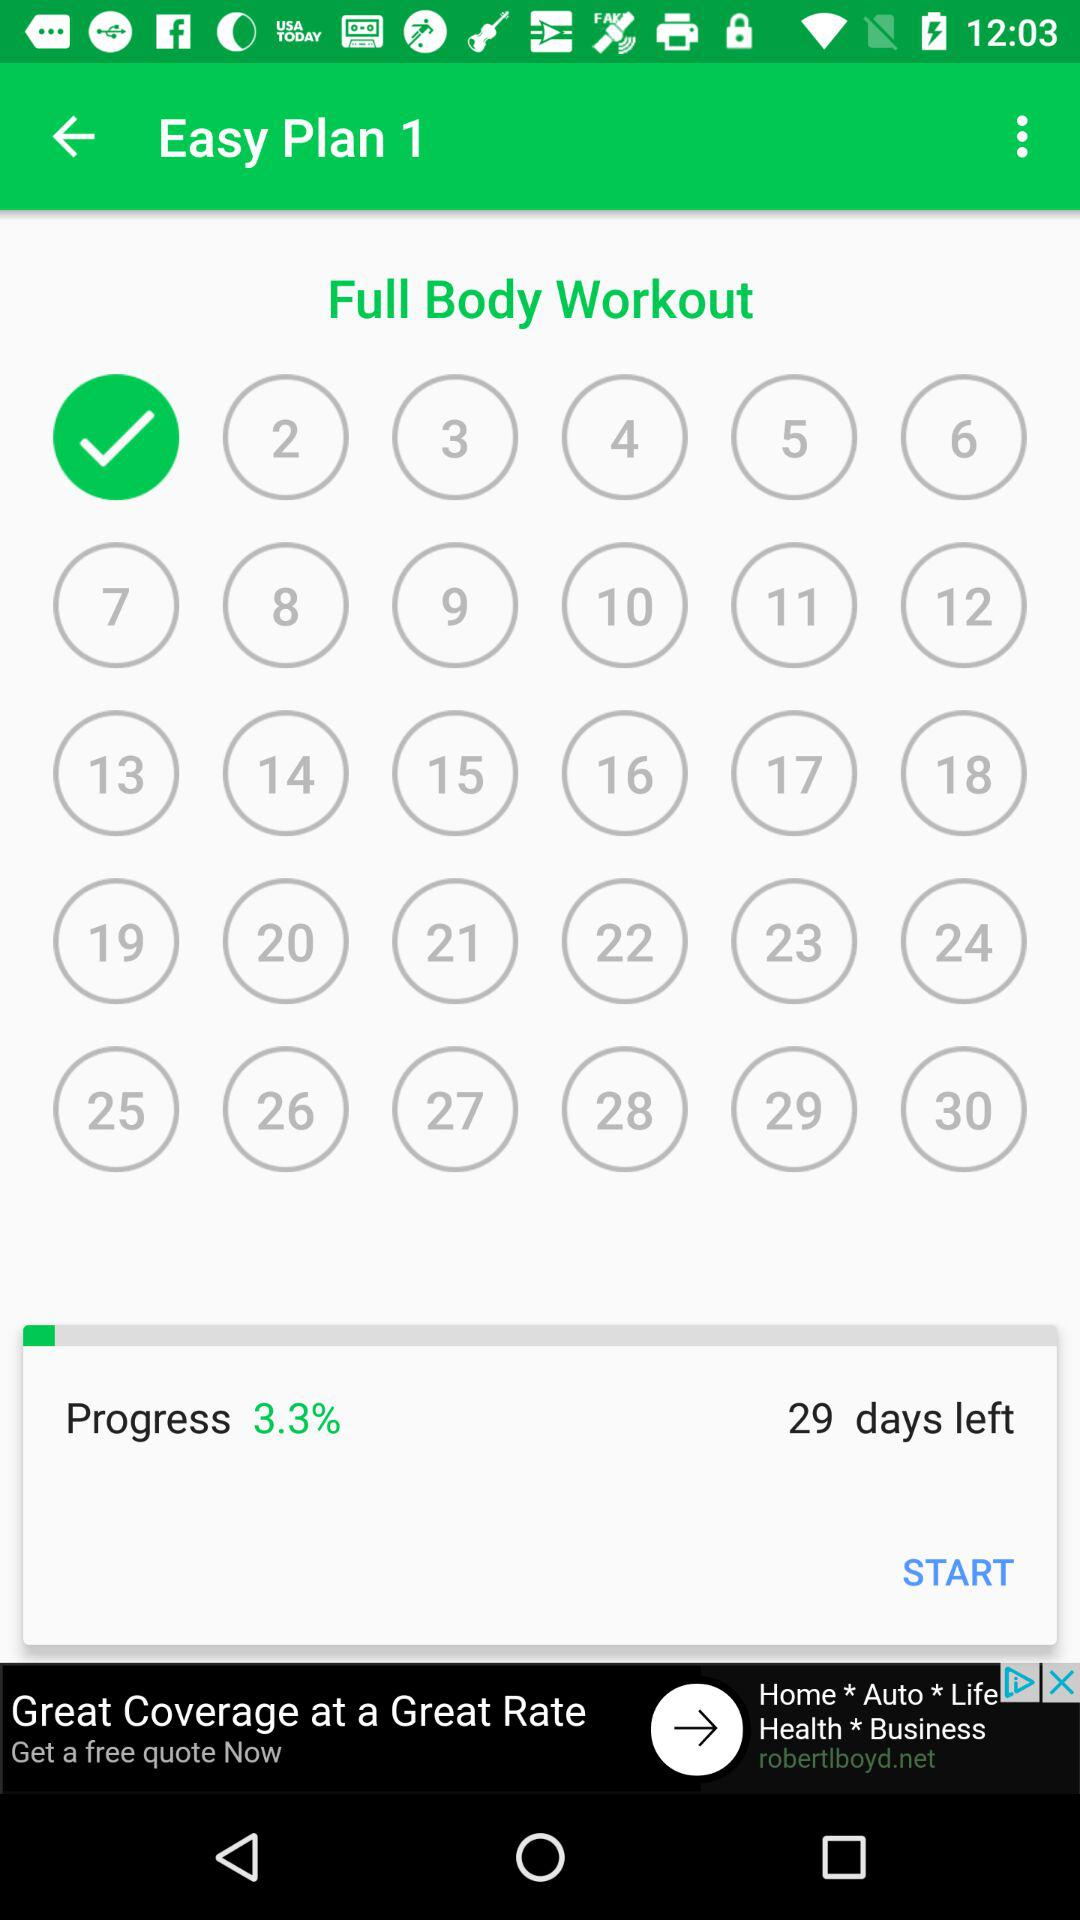What is the progress percentage of the full body workout? The progress percentage of the full body workout is 3.3. 